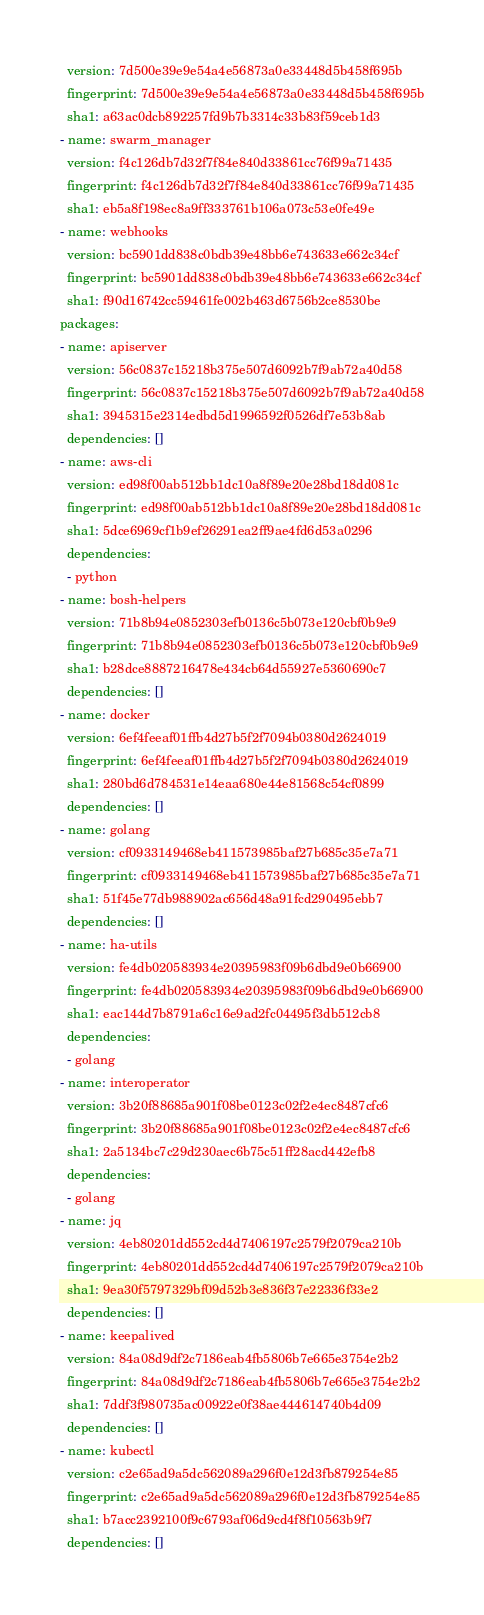<code> <loc_0><loc_0><loc_500><loc_500><_YAML_>  version: 7d500e39e9e54a4e56873a0e33448d5b458f695b
  fingerprint: 7d500e39e9e54a4e56873a0e33448d5b458f695b
  sha1: a63ac0dcb892257fd9b7b3314c33b83f59ceb1d3
- name: swarm_manager
  version: f4c126db7d32f7f84e840d33861cc76f99a71435
  fingerprint: f4c126db7d32f7f84e840d33861cc76f99a71435
  sha1: eb5a8f198ec8a9ff333761b106a073c53e0fe49e
- name: webhooks
  version: bc5901dd838c0bdb39e48bb6e743633e662c34cf
  fingerprint: bc5901dd838c0bdb39e48bb6e743633e662c34cf
  sha1: f90d16742cc59461fe002b463d6756b2ce8530be
packages:
- name: apiserver
  version: 56c0837c15218b375e507d6092b7f9ab72a40d58
  fingerprint: 56c0837c15218b375e507d6092b7f9ab72a40d58
  sha1: 3945315e2314edbd5d1996592f0526df7e53b8ab
  dependencies: []
- name: aws-cli
  version: ed98f00ab512bb1dc10a8f89e20e28bd18dd081c
  fingerprint: ed98f00ab512bb1dc10a8f89e20e28bd18dd081c
  sha1: 5dce6969cf1b9ef26291ea2ff9ae4fd6d53a0296
  dependencies:
  - python
- name: bosh-helpers
  version: 71b8b94e0852303efb0136c5b073e120cbf0b9e9
  fingerprint: 71b8b94e0852303efb0136c5b073e120cbf0b9e9
  sha1: b28dce8887216478e434cb64d55927e5360690c7
  dependencies: []
- name: docker
  version: 6ef4feeaf01ffb4d27b5f2f7094b0380d2624019
  fingerprint: 6ef4feeaf01ffb4d27b5f2f7094b0380d2624019
  sha1: 280bd6d784531e14eaa680e44e81568c54cf0899
  dependencies: []
- name: golang
  version: cf0933149468eb411573985baf27b685c35e7a71
  fingerprint: cf0933149468eb411573985baf27b685c35e7a71
  sha1: 51f45e77db988902ac656d48a91fcd290495ebb7
  dependencies: []
- name: ha-utils
  version: fe4db020583934e20395983f09b6dbd9e0b66900
  fingerprint: fe4db020583934e20395983f09b6dbd9e0b66900
  sha1: eac144d7b8791a6c16e9ad2fc04495f3db512cb8
  dependencies:
  - golang
- name: interoperator
  version: 3b20f88685a901f08be0123c02f2e4ec8487cfc6
  fingerprint: 3b20f88685a901f08be0123c02f2e4ec8487cfc6
  sha1: 2a5134bc7c29d230aec6b75c51ff28acd442efb8
  dependencies:
  - golang
- name: jq
  version: 4eb80201dd552cd4d7406197c2579f2079ca210b
  fingerprint: 4eb80201dd552cd4d7406197c2579f2079ca210b
  sha1: 9ea30f5797329bf09d52b3e836f37e22336f33e2
  dependencies: []
- name: keepalived
  version: 84a08d9df2c7186eab4fb5806b7e665e3754e2b2
  fingerprint: 84a08d9df2c7186eab4fb5806b7e665e3754e2b2
  sha1: 7ddf3f980735ac00922e0f38ae444614740b4d09
  dependencies: []
- name: kubectl
  version: c2e65ad9a5dc562089a296f0e12d3fb879254e85
  fingerprint: c2e65ad9a5dc562089a296f0e12d3fb879254e85
  sha1: b7acc2392100f9c6793af06d9cd4f8f10563b9f7
  dependencies: []</code> 